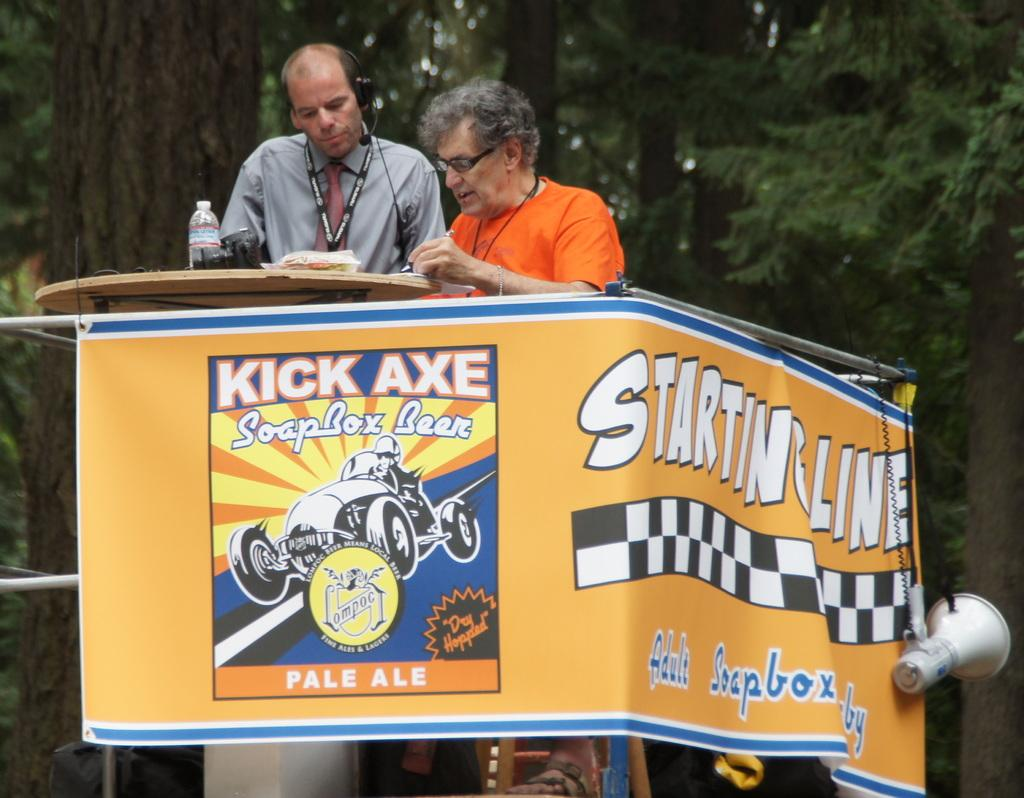How many people are in the image? There are two people in the image. What is the primary object in the image that they might be using? There is a table in the image. What additional item can be seen in the image? There is a banner in the image. What type of natural elements are present in the image? There are trees in the image. What objects are on the table in the image? There is a camera and a bottle on the table in the image. Can you tell me how many balls are on the ground in the image? There are no balls present in the image. 